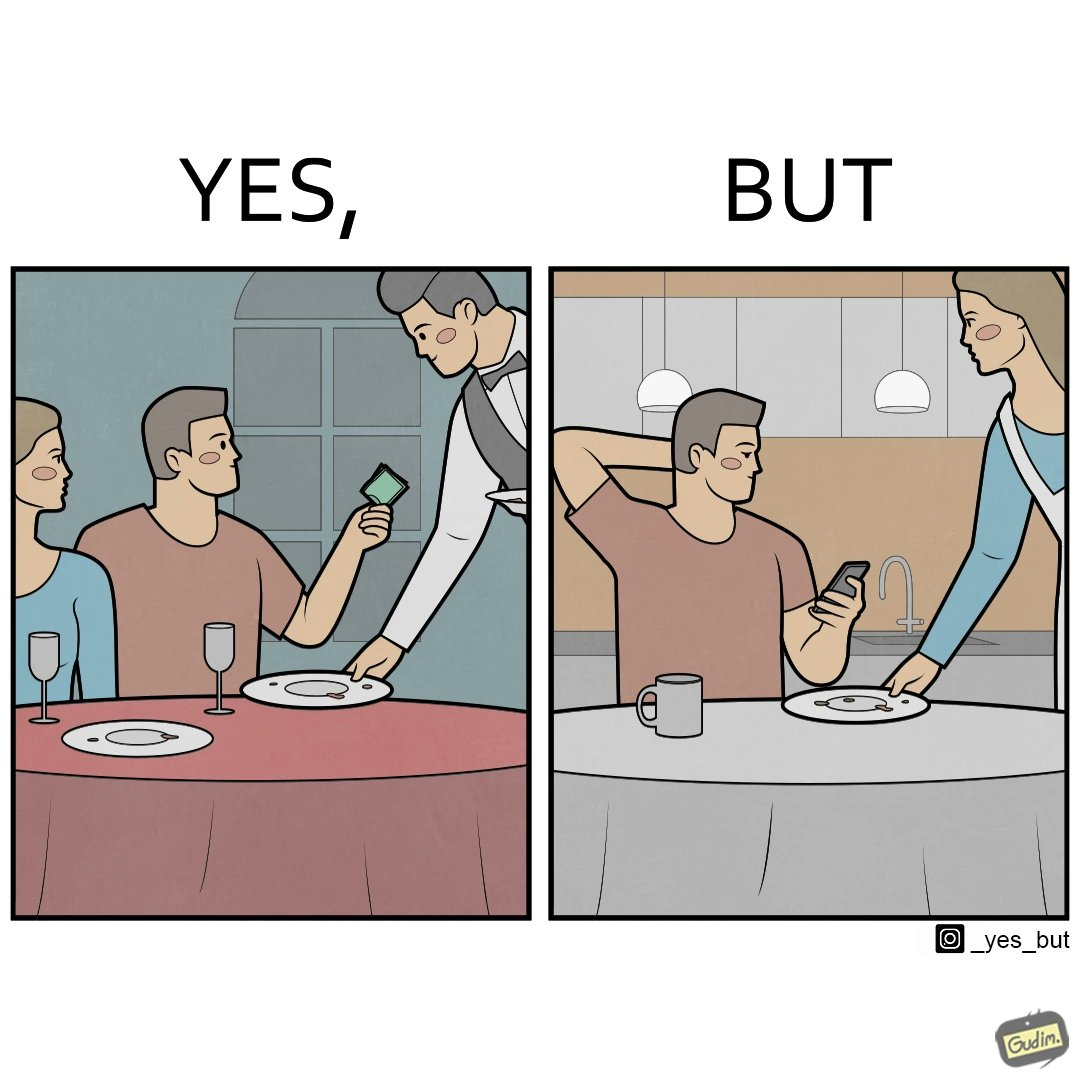Describe the contrast between the left and right parts of this image. In the left part of the image: two people have finished their meal at a restaurant, while the waiter has come to pick up the plates, and the man is tipping the waiter. In the right part of the image: a man in his house has finished his meal while checking his phone, while a woman is picking up his plate. 